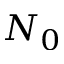<formula> <loc_0><loc_0><loc_500><loc_500>N _ { 0 }</formula> 